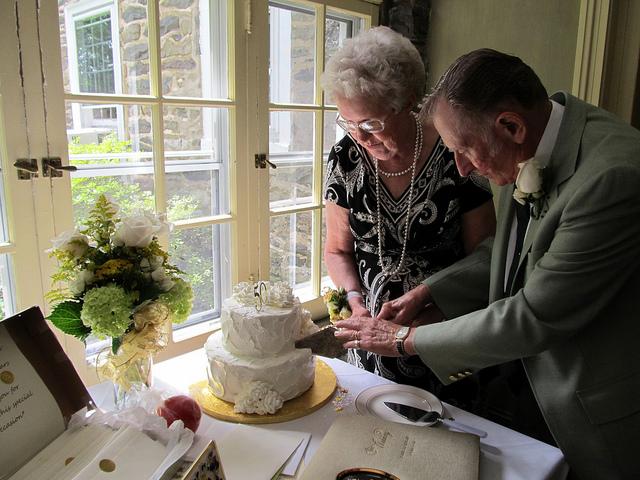What is on the plate?
Keep it brief. Cake. How many people shown?
Concise answer only. 2. What color is the frosting on the cake?
Be succinct. White. 